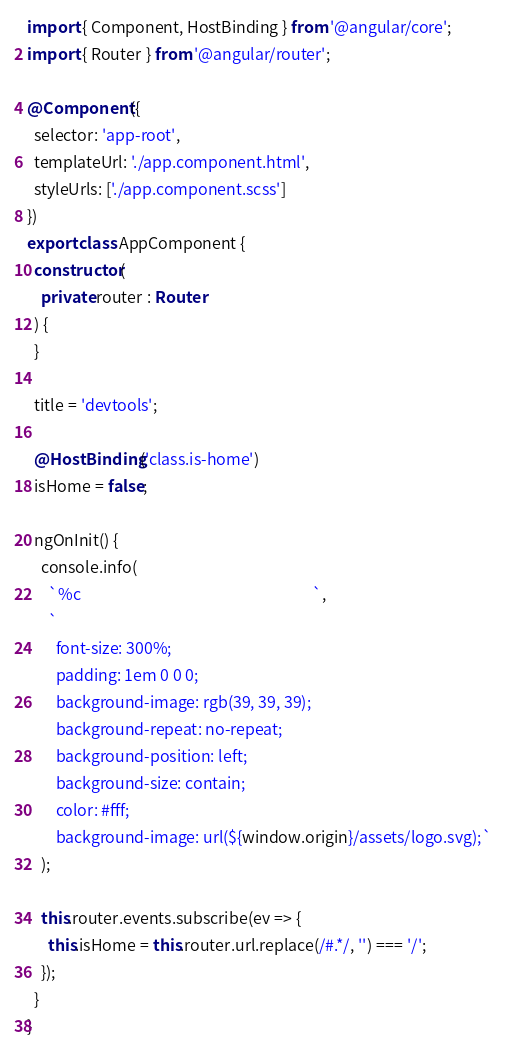Convert code to text. <code><loc_0><loc_0><loc_500><loc_500><_TypeScript_>import { Component, HostBinding } from '@angular/core';
import { Router } from '@angular/router';

@Component({
  selector: 'app-root',
  templateUrl: './app.component.html',
  styleUrls: ['./app.component.scss']
})
export class AppComponent {
  constructor(
    private router : Router
  ) {
  }

  title = 'devtools';

  @HostBinding('class.is-home')
  isHome = false;

  ngOnInit() {
    console.info(
      `%c                                                                 `, 
      `
        font-size: 300%; 
        padding: 1em 0 0 0; 
        background-image: rgb(39, 39, 39); 
        background-repeat: no-repeat;
        background-position: left;
        background-size: contain;
        color: #fff; 
        background-image: url(${window.origin}/assets/logo.svg);`
    );
    
    this.router.events.subscribe(ev => {
      this.isHome = this.router.url.replace(/#.*/, '') === '/';
    });
  }
}
</code> 